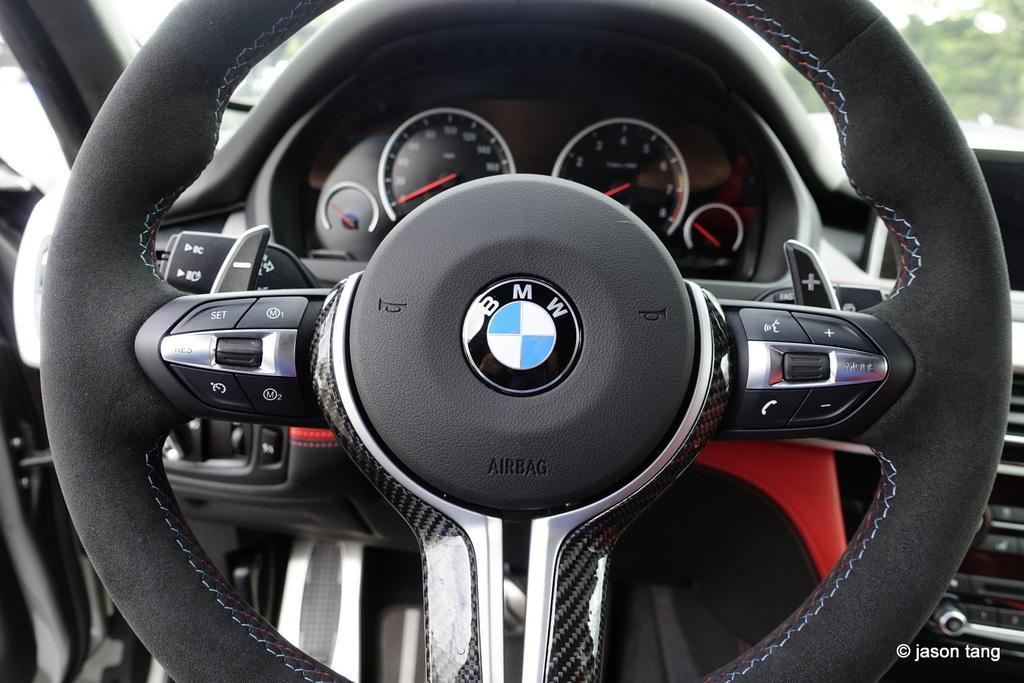Please provide a concise description of this image. In this image I can see black colour steering and speedometer of a vehicle. I can also see something is written at few places and here I can see watermark. 